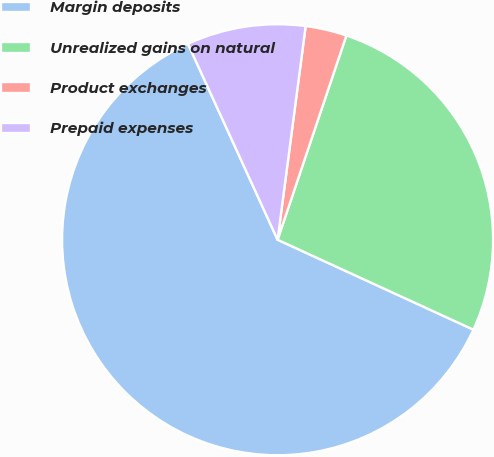Convert chart. <chart><loc_0><loc_0><loc_500><loc_500><pie_chart><fcel>Margin deposits<fcel>Unrealized gains on natural<fcel>Product exchanges<fcel>Prepaid expenses<nl><fcel>61.32%<fcel>26.68%<fcel>3.09%<fcel>8.91%<nl></chart> 